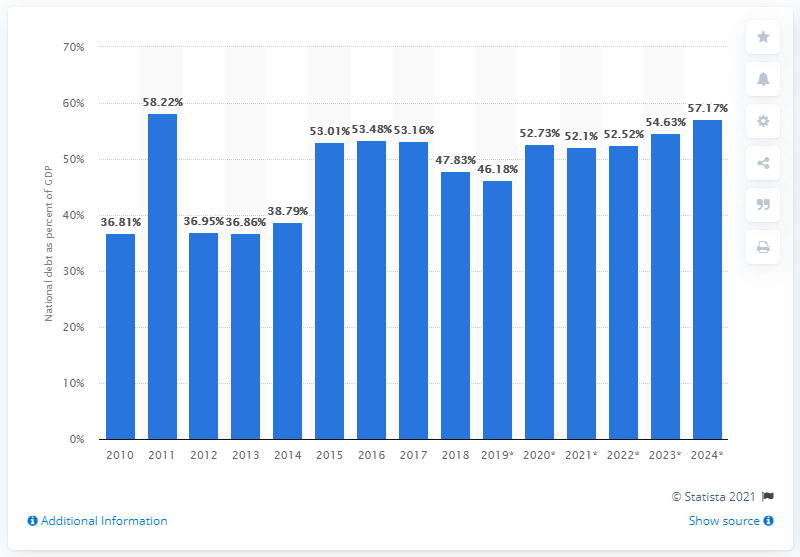Identify some key points in this picture. According to data from 2018, the national debt of Belarus accounted for approximately 47.83% of the country's Gross Domestic Product (GDP). 